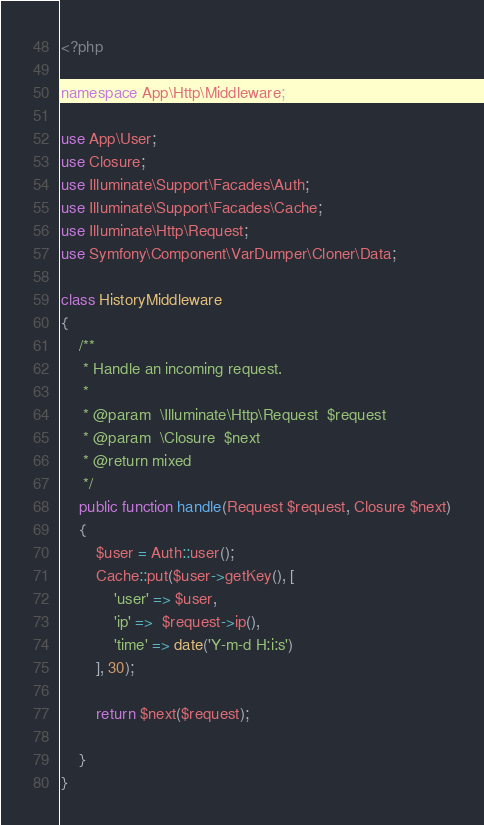Convert code to text. <code><loc_0><loc_0><loc_500><loc_500><_PHP_><?php

namespace App\Http\Middleware;

use App\User;
use Closure;
use Illuminate\Support\Facades\Auth;
use Illuminate\Support\Facades\Cache;
use Illuminate\Http\Request;
use Symfony\Component\VarDumper\Cloner\Data;

class HistoryMiddleware
{
    /**
     * Handle an incoming request.
     *
     * @param  \Illuminate\Http\Request  $request
     * @param  \Closure  $next
     * @return mixed
     */
    public function handle(Request $request, Closure $next)
    {
        $user = Auth::user();
        Cache::put($user->getKey(), [
            'user' => $user,
            'ip' =>  $request->ip(),
            'time' => date('Y-m-d H:i:s')
        ], 30);

        return $next($request);

    }
}
</code> 